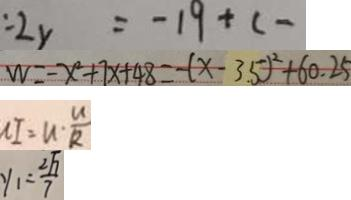Convert formula to latex. <formula><loc_0><loc_0><loc_500><loc_500>: 2 y = - 1 9 + ( - 
 W = - x ^ { 2 } + 7 x + 4 8 = - ( x - 3 . 5 ) ^ { 2 } + 6 0 . 2 5 
 n I = u \cdot \frac { u } { R } 
 y _ { 1 } = \frac { 2 \sqrt { 7 } } { 7 }</formula> 